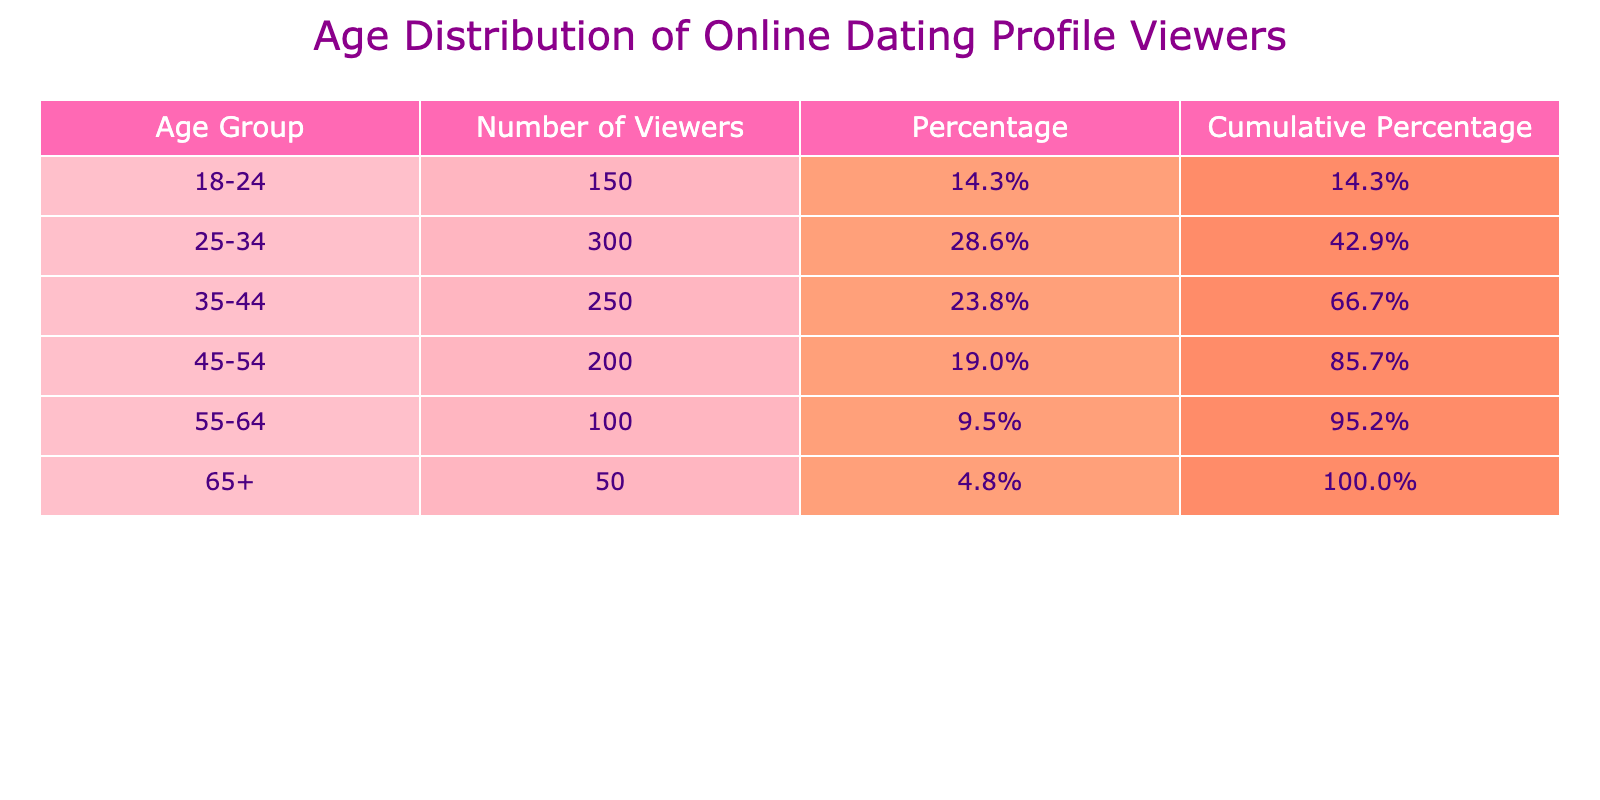What is the age group with the highest number of viewers? By looking at the "Number of Viewers" column, it's clear that the "25-34" age group has the highest count of 300 viewers.
Answer: 25-34 How many viewers belong to the age group of 18-24? The "Number of Viewers" for the age group "18-24" is listed directly in the table as 150.
Answer: 150 What is the total number of viewers across all age groups? To find the total, sum all viewers' numbers: 150 + 300 + 250 + 200 + 100 + 50 = 1050.
Answer: 1050 What percentage of the total viewers are aged 65 and older? The number of viewers aged "65+" is 50. To find the percentage, divide by the total viewers (1050) and multiply by 100: (50 / 1050) * 100 = 4.8%.
Answer: 4.8% Is there a higher number of viewers in the age group of 35-44 compared to 45-54? Yes, the number of viewers aged "35-44" is 250, while "45-54" has 200 viewers. Therefore, 250 is greater than 200.
Answer: Yes What is the cumulative percentage of viewers up to the age group of 45-54? The cumulative percentage for "45-54" is checked by adding the previous percentages: 14.3% (18-24) + 28.6% (25-34) + 23.8% (35-44) + 19.0% (45-54) = 85.7%.
Answer: 85.7% If we combine the number of viewers from the age groups 55-64 and 65+, how many viewers are there? Adding viewers from "55-64" (100) and "65+" (50) gives: 100 + 50 = 150 viewers.
Answer: 150 What is the average number of viewers across all age groups? Divide the total number of viewers (1050) by the number of age groups (6): 1050 / 6 = 175.
Answer: 175 In terms of cumulative percentage, which age group has the smallest value? By checking the cumulative percentages, "65+" shows the lowest percentage at 4.8%, indicating it has the smallest cumulative value among the groups.
Answer: 65+ 